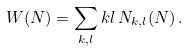<formula> <loc_0><loc_0><loc_500><loc_500>W ( N ) = \sum _ { k , l } k l \, N _ { k , l } ( N ) \, .</formula> 